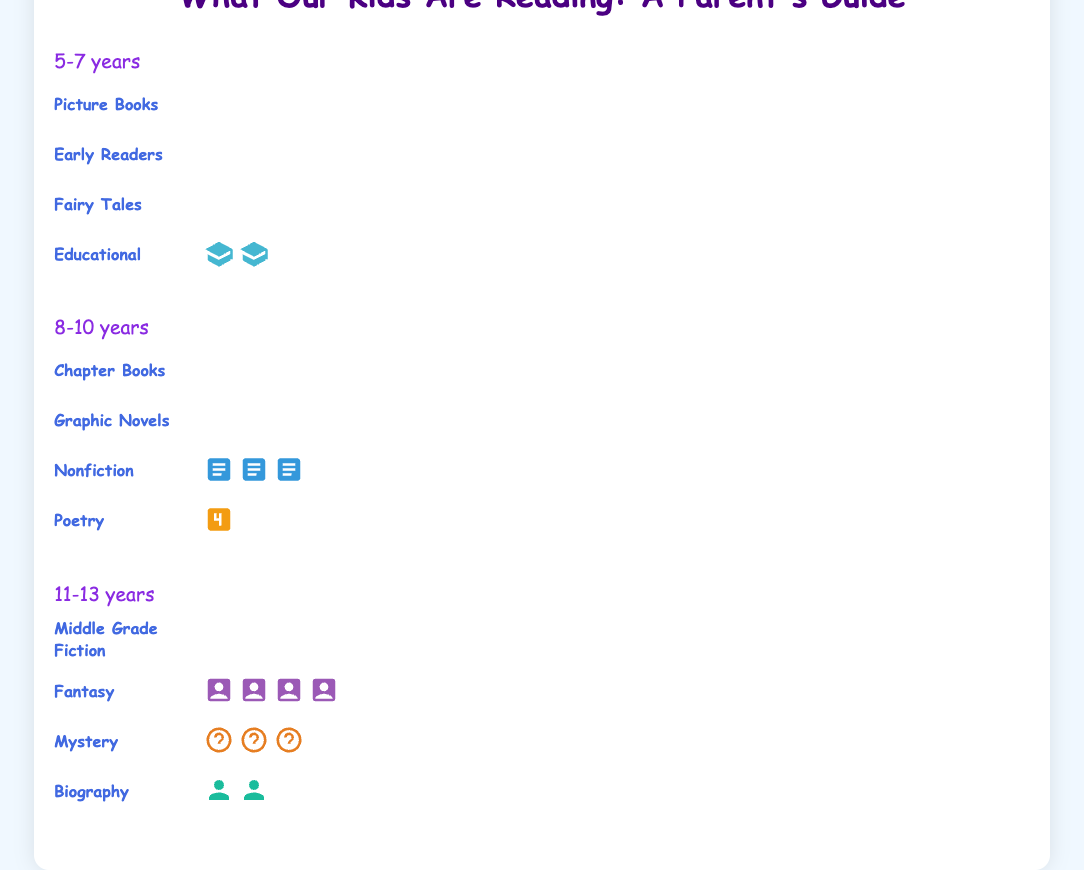What type of books are read most by children aged 5-7? To determine the most popular book type for the 5-7 age group, refer to the figure in the "5-7 years" section and identify the category with the highest count.
Answer: Picture Books How many types of books are read by children aged 11-13? Count the different book categories listed in the "11-13 years" group.
Answer: 4 Which age group reads the most books in total? Add up the book counts for each age group and compare: 5-7 years (8+5+3+2=18), 8-10 years (7+5+3+1=16), 11-13 years (6+4+3+2=15).
Answer: 5-7 years Which type of book is equally read by both the 5-7 and 8-10 age groups? Examine both the 5-7 years and 8-10 years sections to find a category with the same count in both.
Answer: None Do children aged 8-10 read more Graphic Novels or Nonfiction books? Compare the counts for Graphic Novels and Nonfiction in the "8-10 years" section.
Answer: Graphic Novels How many more Fairy Tales are read than Poetry by children aged 5-7? Subtract the number of Poetry books read by 5-7 year olds from the number of Fairy Tales read: 3 - 1 = 2.
Answer: 2 What type of books do children aged 11-13 read the least? Look for the book category with the lowest count in the "11-13 years" section.
Answer: Biography What is the total count of Mystery and Fairy Tales books read by all age groups combined? Add the counts of Mystery and Fairy Tales books from all age groups: 3 (11-13 years) + 0 (8-10 years) + 3 (5-7 years) = 6.
Answer: 6 Which age group reads fewer Nonfiction books, 8-10 years or 11-13 years? Compare the counts of Nonfiction books in the "8-10 years" and "11-13 years" sections.
Answer: 11-13 years How many more Picture Books are read compared to Educational books by children aged 5-7? Subtract the number of Educational books from Picture Books in the "5-7 years" section: 8 - 2 = 6.
Answer: 6 